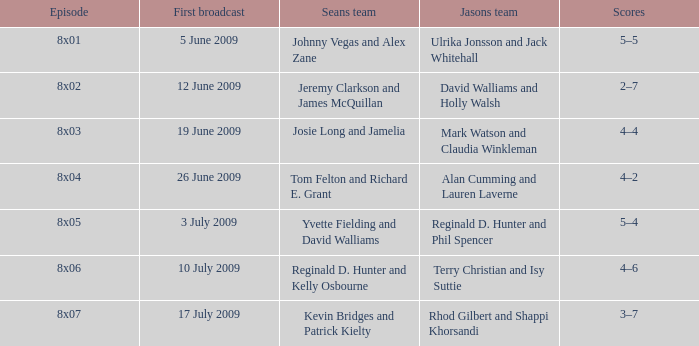What is the transmission date when jason's team comprises rhod gilbert and shappi khorsandi? 17 July 2009. 